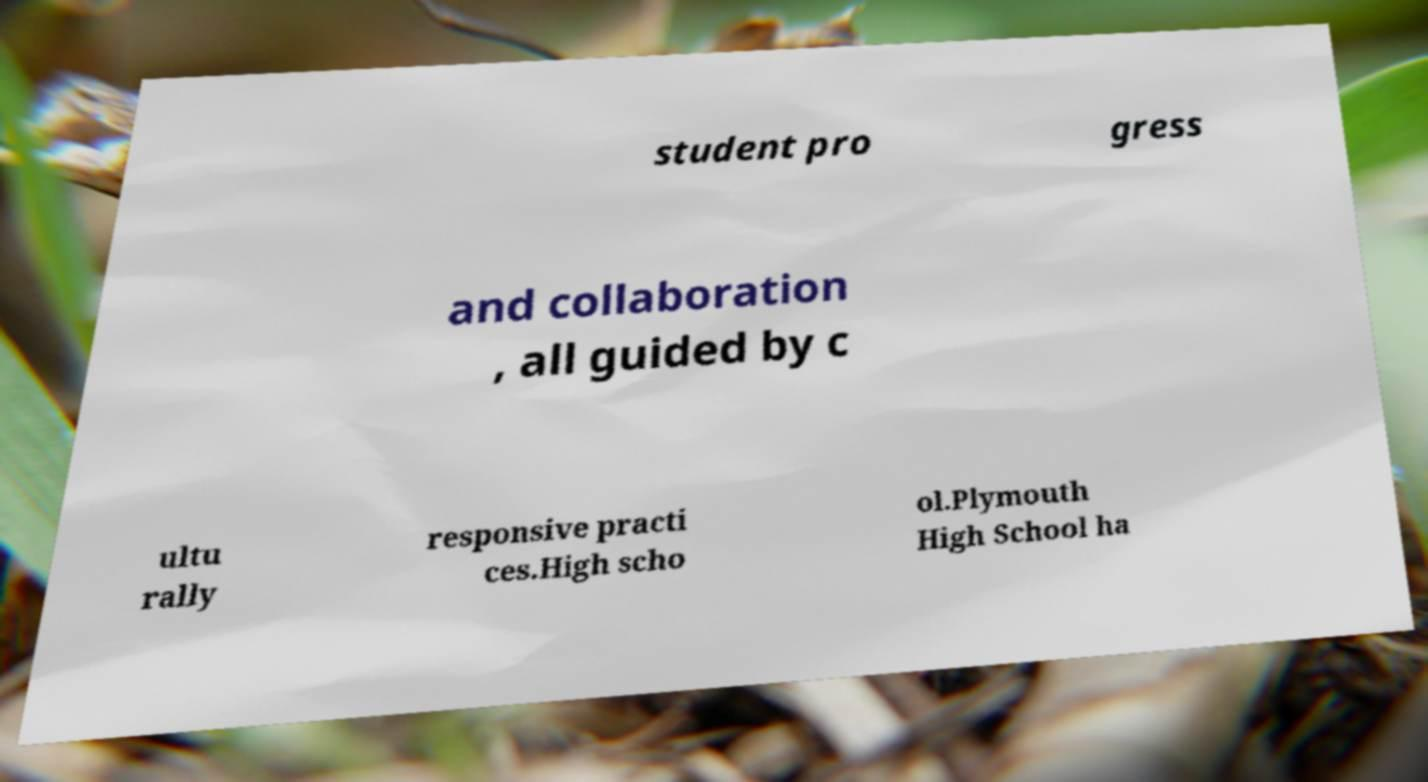There's text embedded in this image that I need extracted. Can you transcribe it verbatim? student pro gress and collaboration , all guided by c ultu rally responsive practi ces.High scho ol.Plymouth High School ha 